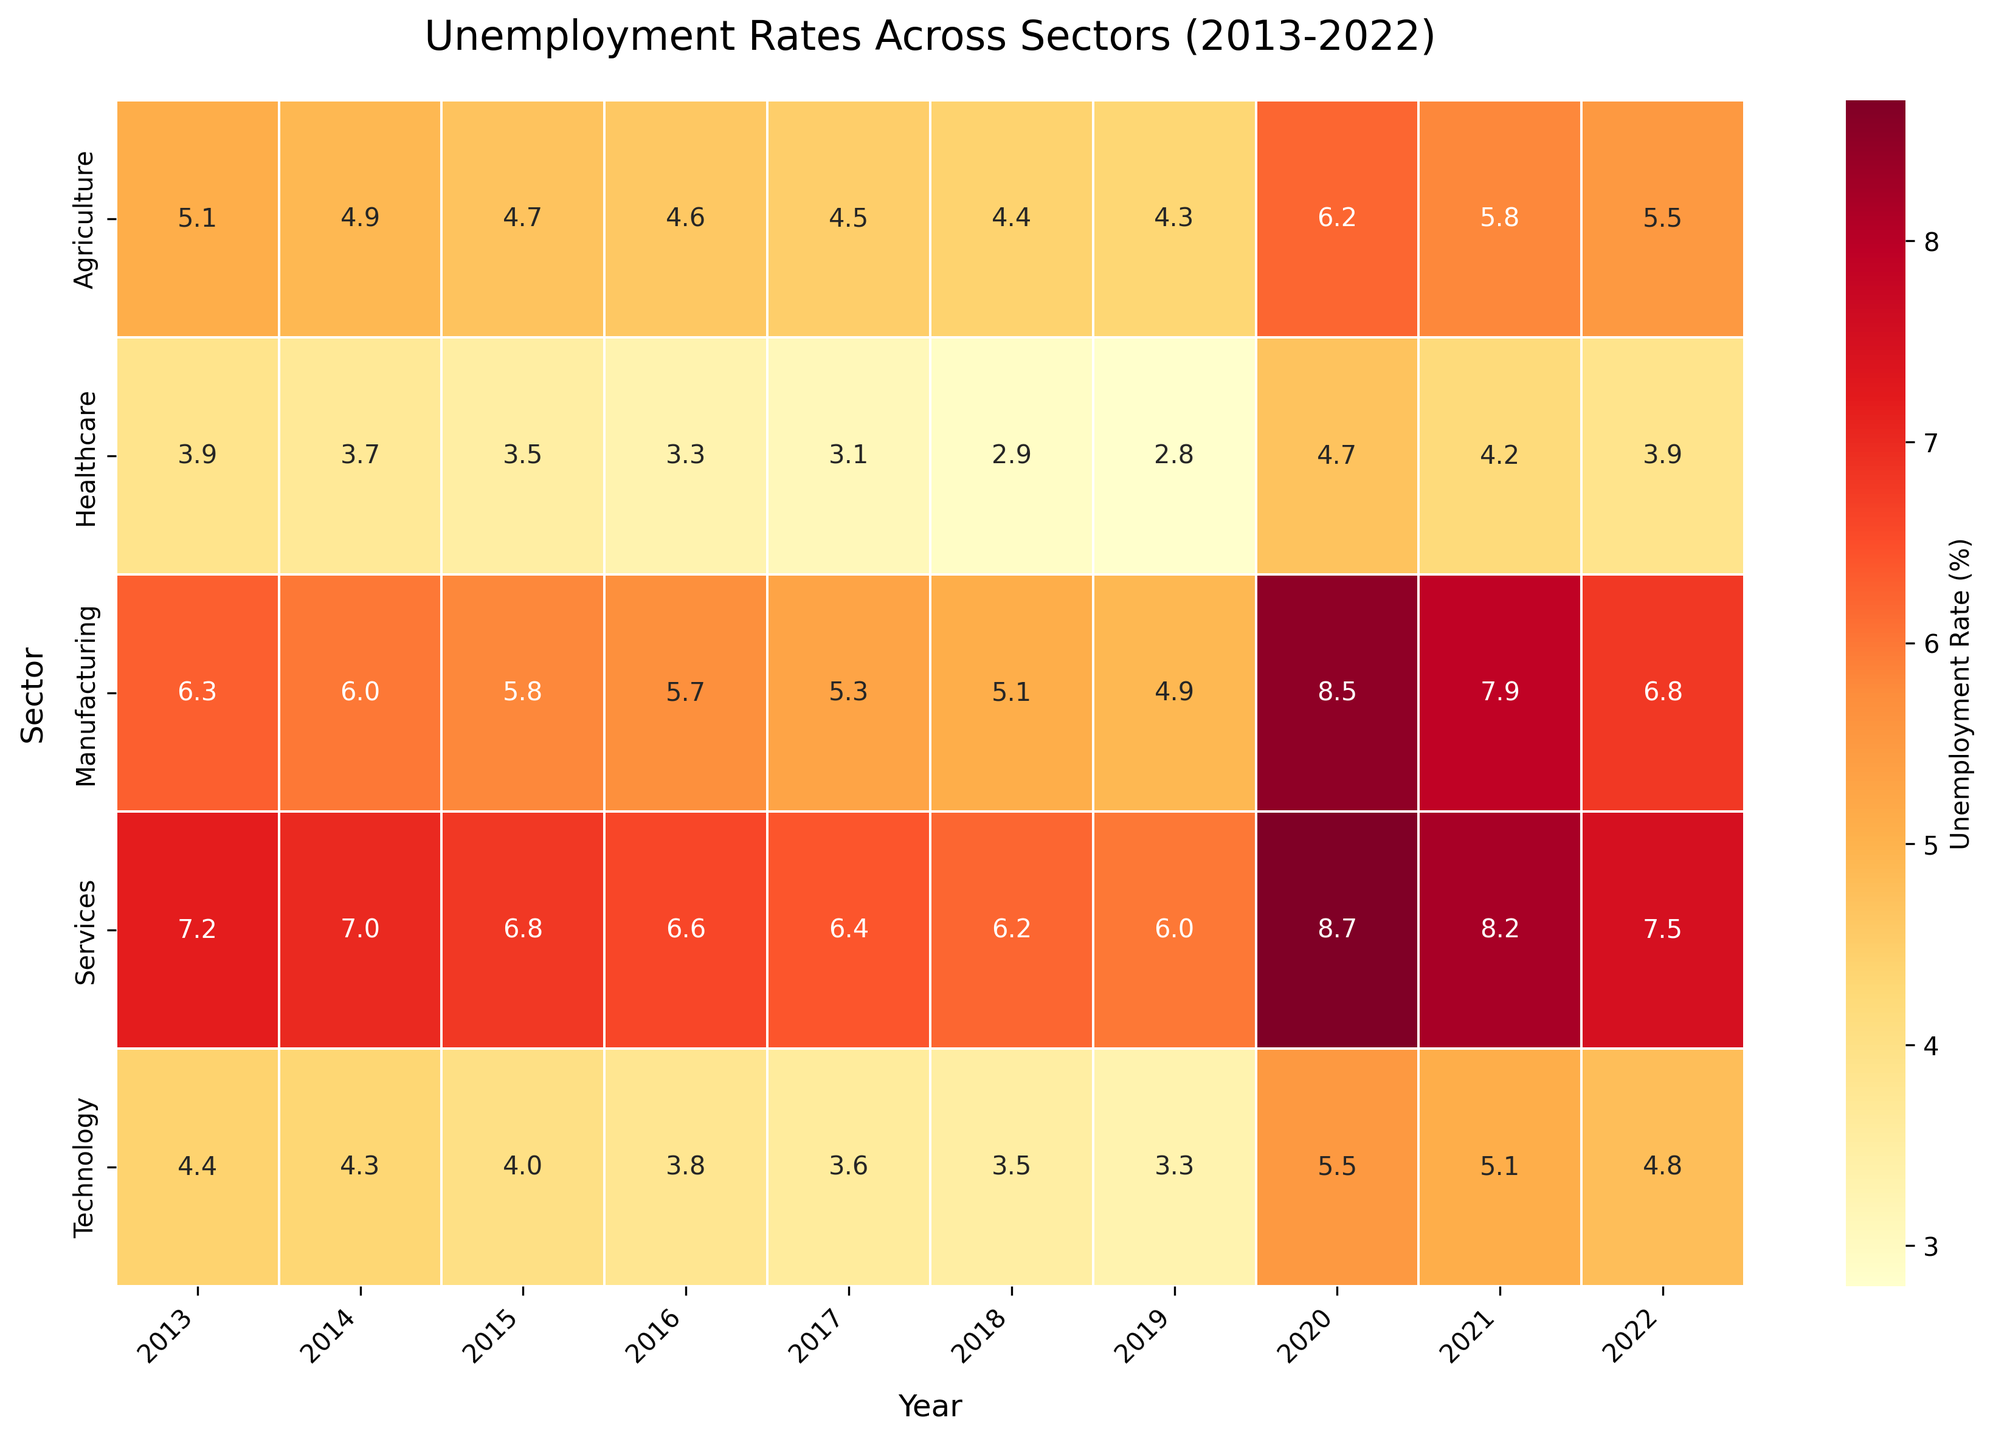What's the title of the heatmap? The title of the heatmap is usually displayed at the top of the plot.
Answer: Unemployment Rates Across Sectors (2013-2022) Which sector had the highest unemployment rate in 2020? Locate the column for the year 2020, then find the highest value within that column, and identify the corresponding sector.
Answer: Services What was the unemployment rate in the Healthcare sector in 2015? Find the row for Healthcare and the column for the year 2015, and check the intersection value.
Answer: 3.5% Which year did the Manufacturing sector experience its lowest unemployment rate? Look along the row for Manufacturing and identify the year with the minimum value.
Answer: 2019 Compare the unemployment rates of the Agriculture sector between 2019 and 2020. How much did it change? Compare the rate in 2019 (4.3%) with that in 2020 (6.2%) and calculate the change: 6.2% - 4.3% = 1.9%.
Answer: Increased by 1.9% Which sector showed the least fluctuation in unemployment rates over the decade? Identify the sector with the smallest range of values in its row. Specifically, Healthcare has the smallest fluctuations around 3.4% (from 2.8% to 4.7%).
Answer: Healthcare What's the average unemployment rate for the Technology sector across the decade? Sum up the unemployment rates for the Technology sector from 2013 to 2022 and divide by the number of years (10). (4.4 + 4.3 + 4.0 + 3.8 + 3.6 + 3.5 + 3.3 + 5.5 + 5.1 + 4.8)/10 = 4.23%.
Answer: 4.23% Which sector had the most consistent annual decline in unemployment rate from 2013 to 2019? Identify the sector where the unemployment rate decreases every year from 2013 to 2019.
Answer: Agriculture 